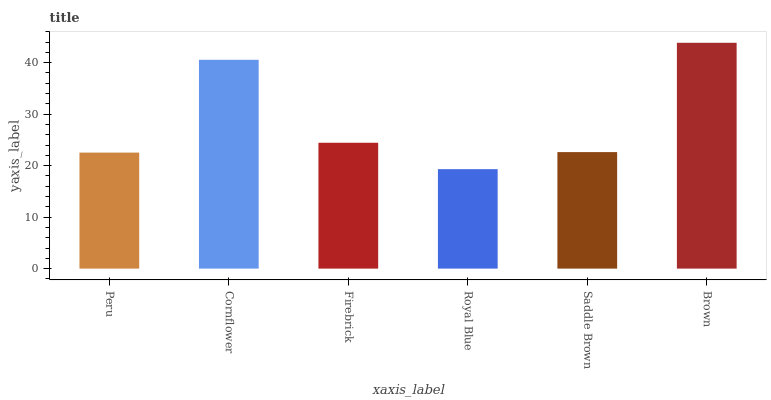Is Royal Blue the minimum?
Answer yes or no. Yes. Is Brown the maximum?
Answer yes or no. Yes. Is Cornflower the minimum?
Answer yes or no. No. Is Cornflower the maximum?
Answer yes or no. No. Is Cornflower greater than Peru?
Answer yes or no. Yes. Is Peru less than Cornflower?
Answer yes or no. Yes. Is Peru greater than Cornflower?
Answer yes or no. No. Is Cornflower less than Peru?
Answer yes or no. No. Is Firebrick the high median?
Answer yes or no. Yes. Is Saddle Brown the low median?
Answer yes or no. Yes. Is Saddle Brown the high median?
Answer yes or no. No. Is Cornflower the low median?
Answer yes or no. No. 